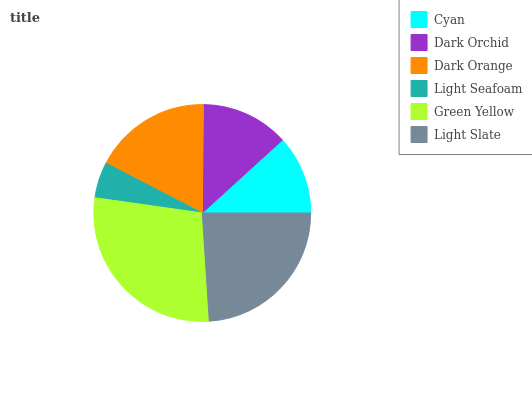Is Light Seafoam the minimum?
Answer yes or no. Yes. Is Green Yellow the maximum?
Answer yes or no. Yes. Is Dark Orchid the minimum?
Answer yes or no. No. Is Dark Orchid the maximum?
Answer yes or no. No. Is Dark Orchid greater than Cyan?
Answer yes or no. Yes. Is Cyan less than Dark Orchid?
Answer yes or no. Yes. Is Cyan greater than Dark Orchid?
Answer yes or no. No. Is Dark Orchid less than Cyan?
Answer yes or no. No. Is Dark Orange the high median?
Answer yes or no. Yes. Is Dark Orchid the low median?
Answer yes or no. Yes. Is Cyan the high median?
Answer yes or no. No. Is Green Yellow the low median?
Answer yes or no. No. 